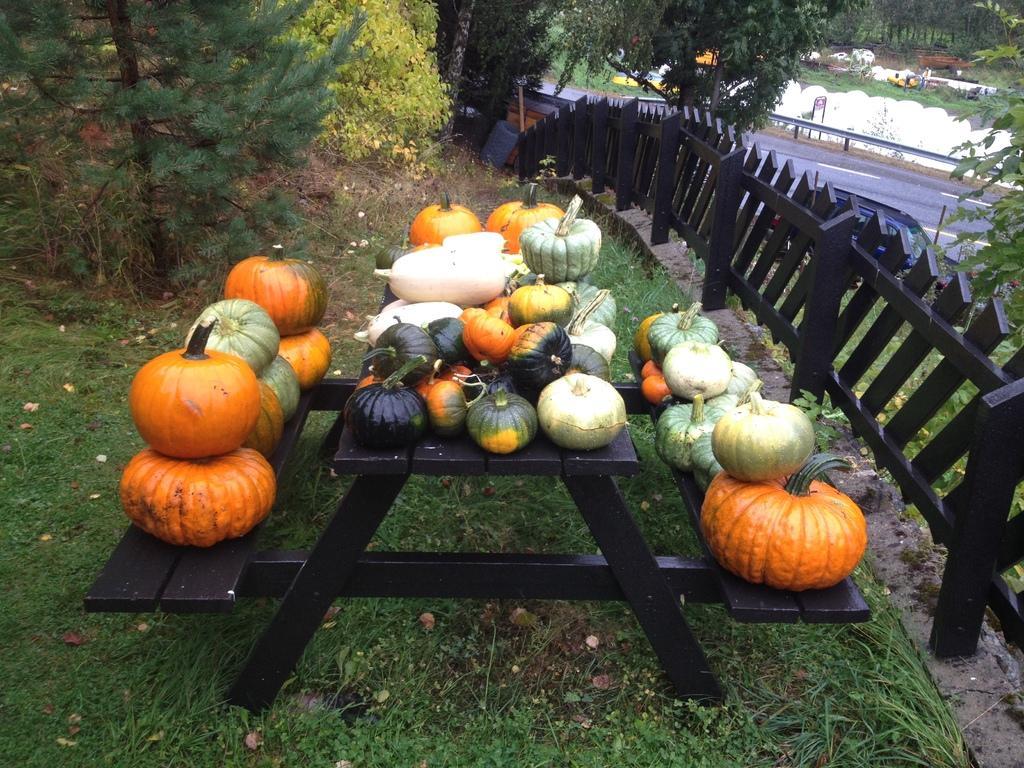How would you summarize this image in a sentence or two? The image is taken in the garden of a house. In the foreground of the picture there is a bench, on the bench there are pumpkin. On the right there are plants, tree, railing, car and road. In the center of the picture there are trees, plants and grass. At the bottom there are plants and grass. In the background there are trees, railing, plants and other objects. 